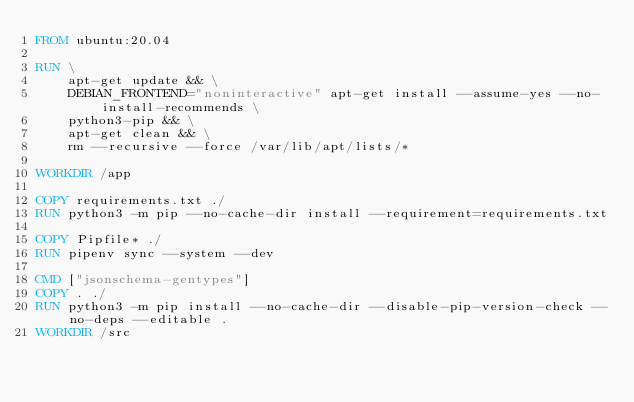<code> <loc_0><loc_0><loc_500><loc_500><_Dockerfile_>FROM ubuntu:20.04

RUN \
    apt-get update && \
    DEBIAN_FRONTEND="noninteractive" apt-get install --assume-yes --no-install-recommends \
    python3-pip && \
    apt-get clean && \
    rm --recursive --force /var/lib/apt/lists/*

WORKDIR /app

COPY requirements.txt ./
RUN python3 -m pip --no-cache-dir install --requirement=requirements.txt

COPY Pipfile* ./
RUN	pipenv sync --system --dev

CMD ["jsonschema-gentypes"]
COPY . ./
RUN python3 -m pip install --no-cache-dir --disable-pip-version-check --no-deps --editable .
WORKDIR /src
</code> 